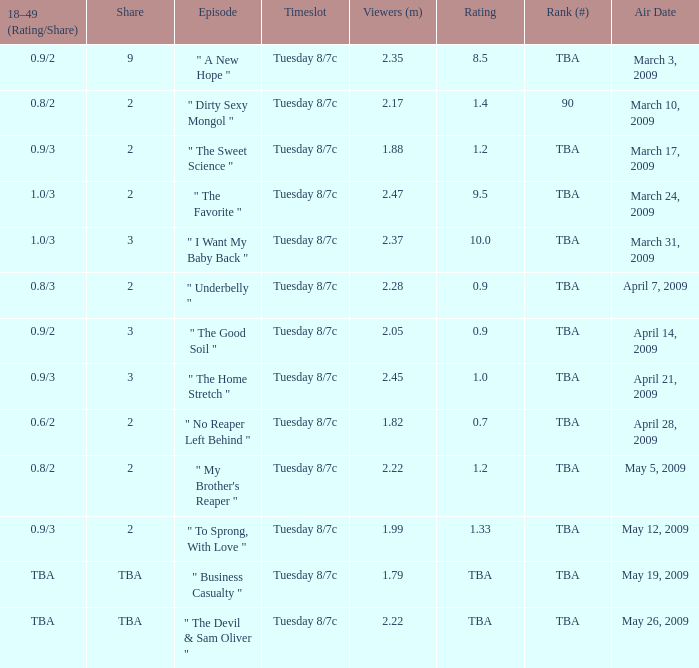What percentage does the 18-49 age group (rating/share) represent with a value of 0.8/3? 2.0. 